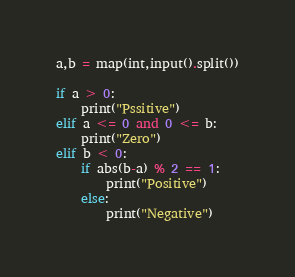Convert code to text. <code><loc_0><loc_0><loc_500><loc_500><_Python_>
a,b = map(int,input().split())

if a > 0:
    print("Pssitive")
elif a <= 0 and 0 <= b:
    print("Zero")
elif b < 0:
    if abs(b-a) % 2 == 1:
        print("Positive")
    else:
        print("Negative")
</code> 